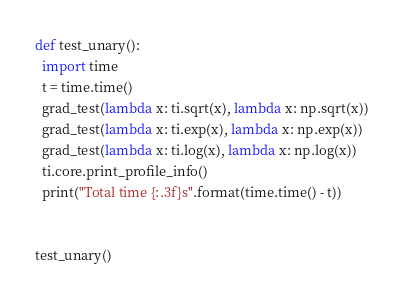<code> <loc_0><loc_0><loc_500><loc_500><_Python_>

def test_unary():
  import time
  t = time.time()
  grad_test(lambda x: ti.sqrt(x), lambda x: np.sqrt(x))
  grad_test(lambda x: ti.exp(x), lambda x: np.exp(x))
  grad_test(lambda x: ti.log(x), lambda x: np.log(x))
  ti.core.print_profile_info()
  print("Total time {:.3f}s".format(time.time() - t))


test_unary()
</code> 